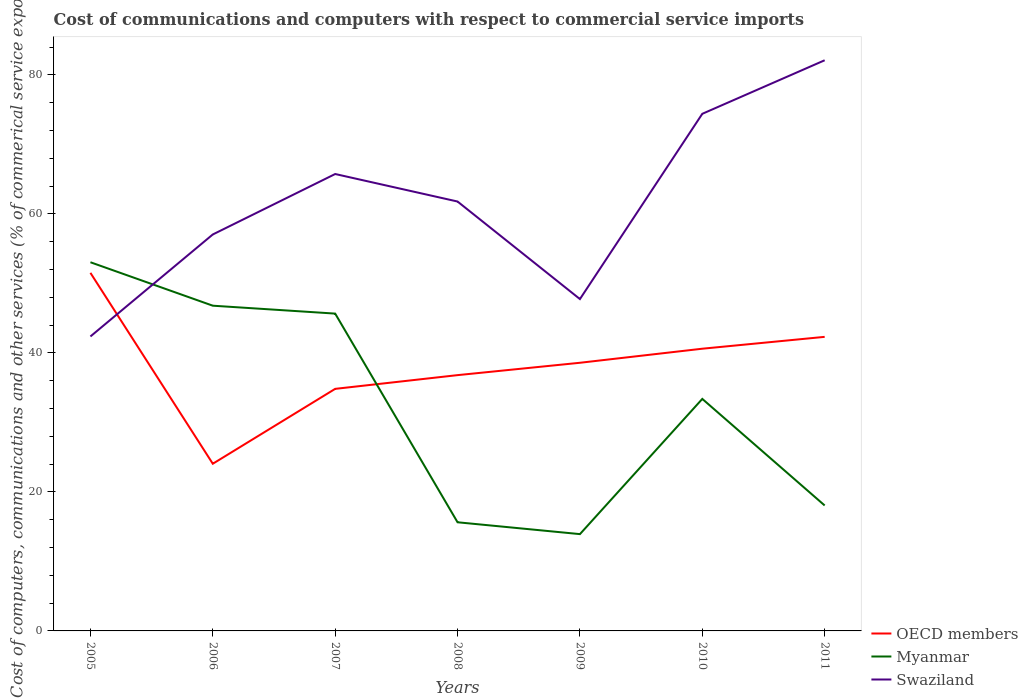How many different coloured lines are there?
Make the answer very short. 3. Across all years, what is the maximum cost of communications and computers in Myanmar?
Your response must be concise. 13.93. What is the total cost of communications and computers in Swaziland in the graph?
Offer a very short reply. -4.74. What is the difference between the highest and the second highest cost of communications and computers in Myanmar?
Ensure brevity in your answer.  39.11. What is the difference between the highest and the lowest cost of communications and computers in Swaziland?
Ensure brevity in your answer.  4. Is the cost of communications and computers in OECD members strictly greater than the cost of communications and computers in Myanmar over the years?
Provide a short and direct response. No. How many legend labels are there?
Ensure brevity in your answer.  3. What is the title of the graph?
Give a very brief answer. Cost of communications and computers with respect to commercial service imports. What is the label or title of the X-axis?
Provide a succinct answer. Years. What is the label or title of the Y-axis?
Provide a short and direct response. Cost of computers, communications and other services (% of commerical service exports). What is the Cost of computers, communications and other services (% of commerical service exports) in OECD members in 2005?
Provide a short and direct response. 51.51. What is the Cost of computers, communications and other services (% of commerical service exports) of Myanmar in 2005?
Your answer should be very brief. 53.04. What is the Cost of computers, communications and other services (% of commerical service exports) of Swaziland in 2005?
Ensure brevity in your answer.  42.36. What is the Cost of computers, communications and other services (% of commerical service exports) in OECD members in 2006?
Keep it short and to the point. 24.05. What is the Cost of computers, communications and other services (% of commerical service exports) of Myanmar in 2006?
Make the answer very short. 46.79. What is the Cost of computers, communications and other services (% of commerical service exports) in Swaziland in 2006?
Your answer should be very brief. 57.03. What is the Cost of computers, communications and other services (% of commerical service exports) of OECD members in 2007?
Your answer should be very brief. 34.82. What is the Cost of computers, communications and other services (% of commerical service exports) in Myanmar in 2007?
Provide a short and direct response. 45.65. What is the Cost of computers, communications and other services (% of commerical service exports) of Swaziland in 2007?
Make the answer very short. 65.73. What is the Cost of computers, communications and other services (% of commerical service exports) of OECD members in 2008?
Keep it short and to the point. 36.8. What is the Cost of computers, communications and other services (% of commerical service exports) of Myanmar in 2008?
Provide a short and direct response. 15.63. What is the Cost of computers, communications and other services (% of commerical service exports) in Swaziland in 2008?
Offer a very short reply. 61.77. What is the Cost of computers, communications and other services (% of commerical service exports) of OECD members in 2009?
Offer a very short reply. 38.57. What is the Cost of computers, communications and other services (% of commerical service exports) in Myanmar in 2009?
Your answer should be very brief. 13.93. What is the Cost of computers, communications and other services (% of commerical service exports) in Swaziland in 2009?
Offer a very short reply. 47.74. What is the Cost of computers, communications and other services (% of commerical service exports) in OECD members in 2010?
Offer a very short reply. 40.6. What is the Cost of computers, communications and other services (% of commerical service exports) in Myanmar in 2010?
Give a very brief answer. 33.38. What is the Cost of computers, communications and other services (% of commerical service exports) of Swaziland in 2010?
Keep it short and to the point. 74.39. What is the Cost of computers, communications and other services (% of commerical service exports) in OECD members in 2011?
Provide a succinct answer. 42.3. What is the Cost of computers, communications and other services (% of commerical service exports) in Myanmar in 2011?
Provide a short and direct response. 18.05. What is the Cost of computers, communications and other services (% of commerical service exports) of Swaziland in 2011?
Provide a succinct answer. 82.09. Across all years, what is the maximum Cost of computers, communications and other services (% of commerical service exports) in OECD members?
Your response must be concise. 51.51. Across all years, what is the maximum Cost of computers, communications and other services (% of commerical service exports) in Myanmar?
Provide a succinct answer. 53.04. Across all years, what is the maximum Cost of computers, communications and other services (% of commerical service exports) of Swaziland?
Give a very brief answer. 82.09. Across all years, what is the minimum Cost of computers, communications and other services (% of commerical service exports) in OECD members?
Provide a succinct answer. 24.05. Across all years, what is the minimum Cost of computers, communications and other services (% of commerical service exports) in Myanmar?
Ensure brevity in your answer.  13.93. Across all years, what is the minimum Cost of computers, communications and other services (% of commerical service exports) of Swaziland?
Give a very brief answer. 42.36. What is the total Cost of computers, communications and other services (% of commerical service exports) in OECD members in the graph?
Keep it short and to the point. 268.66. What is the total Cost of computers, communications and other services (% of commerical service exports) of Myanmar in the graph?
Keep it short and to the point. 226.45. What is the total Cost of computers, communications and other services (% of commerical service exports) of Swaziland in the graph?
Provide a short and direct response. 431.12. What is the difference between the Cost of computers, communications and other services (% of commerical service exports) of OECD members in 2005 and that in 2006?
Keep it short and to the point. 27.46. What is the difference between the Cost of computers, communications and other services (% of commerical service exports) in Myanmar in 2005 and that in 2006?
Keep it short and to the point. 6.25. What is the difference between the Cost of computers, communications and other services (% of commerical service exports) of Swaziland in 2005 and that in 2006?
Your response must be concise. -14.67. What is the difference between the Cost of computers, communications and other services (% of commerical service exports) in OECD members in 2005 and that in 2007?
Your response must be concise. 16.69. What is the difference between the Cost of computers, communications and other services (% of commerical service exports) of Myanmar in 2005 and that in 2007?
Make the answer very short. 7.39. What is the difference between the Cost of computers, communications and other services (% of commerical service exports) of Swaziland in 2005 and that in 2007?
Ensure brevity in your answer.  -23.37. What is the difference between the Cost of computers, communications and other services (% of commerical service exports) of OECD members in 2005 and that in 2008?
Ensure brevity in your answer.  14.71. What is the difference between the Cost of computers, communications and other services (% of commerical service exports) in Myanmar in 2005 and that in 2008?
Provide a succinct answer. 37.41. What is the difference between the Cost of computers, communications and other services (% of commerical service exports) of Swaziland in 2005 and that in 2008?
Keep it short and to the point. -19.41. What is the difference between the Cost of computers, communications and other services (% of commerical service exports) of OECD members in 2005 and that in 2009?
Offer a very short reply. 12.94. What is the difference between the Cost of computers, communications and other services (% of commerical service exports) of Myanmar in 2005 and that in 2009?
Ensure brevity in your answer.  39.11. What is the difference between the Cost of computers, communications and other services (% of commerical service exports) of Swaziland in 2005 and that in 2009?
Ensure brevity in your answer.  -5.38. What is the difference between the Cost of computers, communications and other services (% of commerical service exports) of OECD members in 2005 and that in 2010?
Offer a terse response. 10.91. What is the difference between the Cost of computers, communications and other services (% of commerical service exports) in Myanmar in 2005 and that in 2010?
Your answer should be compact. 19.66. What is the difference between the Cost of computers, communications and other services (% of commerical service exports) of Swaziland in 2005 and that in 2010?
Your response must be concise. -32.03. What is the difference between the Cost of computers, communications and other services (% of commerical service exports) of OECD members in 2005 and that in 2011?
Provide a succinct answer. 9.21. What is the difference between the Cost of computers, communications and other services (% of commerical service exports) of Myanmar in 2005 and that in 2011?
Ensure brevity in your answer.  34.99. What is the difference between the Cost of computers, communications and other services (% of commerical service exports) in Swaziland in 2005 and that in 2011?
Provide a short and direct response. -39.73. What is the difference between the Cost of computers, communications and other services (% of commerical service exports) in OECD members in 2006 and that in 2007?
Offer a terse response. -10.77. What is the difference between the Cost of computers, communications and other services (% of commerical service exports) of Myanmar in 2006 and that in 2007?
Make the answer very short. 1.14. What is the difference between the Cost of computers, communications and other services (% of commerical service exports) in Swaziland in 2006 and that in 2007?
Provide a succinct answer. -8.7. What is the difference between the Cost of computers, communications and other services (% of commerical service exports) in OECD members in 2006 and that in 2008?
Offer a terse response. -12.75. What is the difference between the Cost of computers, communications and other services (% of commerical service exports) in Myanmar in 2006 and that in 2008?
Provide a short and direct response. 31.16. What is the difference between the Cost of computers, communications and other services (% of commerical service exports) in Swaziland in 2006 and that in 2008?
Provide a short and direct response. -4.74. What is the difference between the Cost of computers, communications and other services (% of commerical service exports) of OECD members in 2006 and that in 2009?
Provide a succinct answer. -14.53. What is the difference between the Cost of computers, communications and other services (% of commerical service exports) in Myanmar in 2006 and that in 2009?
Your answer should be compact. 32.86. What is the difference between the Cost of computers, communications and other services (% of commerical service exports) of Swaziland in 2006 and that in 2009?
Offer a very short reply. 9.29. What is the difference between the Cost of computers, communications and other services (% of commerical service exports) of OECD members in 2006 and that in 2010?
Offer a very short reply. -16.55. What is the difference between the Cost of computers, communications and other services (% of commerical service exports) in Myanmar in 2006 and that in 2010?
Provide a succinct answer. 13.41. What is the difference between the Cost of computers, communications and other services (% of commerical service exports) of Swaziland in 2006 and that in 2010?
Provide a short and direct response. -17.36. What is the difference between the Cost of computers, communications and other services (% of commerical service exports) in OECD members in 2006 and that in 2011?
Make the answer very short. -18.26. What is the difference between the Cost of computers, communications and other services (% of commerical service exports) of Myanmar in 2006 and that in 2011?
Your response must be concise. 28.74. What is the difference between the Cost of computers, communications and other services (% of commerical service exports) of Swaziland in 2006 and that in 2011?
Keep it short and to the point. -25.06. What is the difference between the Cost of computers, communications and other services (% of commerical service exports) of OECD members in 2007 and that in 2008?
Your answer should be very brief. -1.97. What is the difference between the Cost of computers, communications and other services (% of commerical service exports) in Myanmar in 2007 and that in 2008?
Offer a terse response. 30.02. What is the difference between the Cost of computers, communications and other services (% of commerical service exports) of Swaziland in 2007 and that in 2008?
Make the answer very short. 3.96. What is the difference between the Cost of computers, communications and other services (% of commerical service exports) of OECD members in 2007 and that in 2009?
Keep it short and to the point. -3.75. What is the difference between the Cost of computers, communications and other services (% of commerical service exports) of Myanmar in 2007 and that in 2009?
Your answer should be compact. 31.72. What is the difference between the Cost of computers, communications and other services (% of commerical service exports) in Swaziland in 2007 and that in 2009?
Your answer should be very brief. 17.99. What is the difference between the Cost of computers, communications and other services (% of commerical service exports) in OECD members in 2007 and that in 2010?
Keep it short and to the point. -5.78. What is the difference between the Cost of computers, communications and other services (% of commerical service exports) of Myanmar in 2007 and that in 2010?
Give a very brief answer. 12.27. What is the difference between the Cost of computers, communications and other services (% of commerical service exports) of Swaziland in 2007 and that in 2010?
Give a very brief answer. -8.66. What is the difference between the Cost of computers, communications and other services (% of commerical service exports) of OECD members in 2007 and that in 2011?
Your answer should be compact. -7.48. What is the difference between the Cost of computers, communications and other services (% of commerical service exports) of Myanmar in 2007 and that in 2011?
Keep it short and to the point. 27.6. What is the difference between the Cost of computers, communications and other services (% of commerical service exports) of Swaziland in 2007 and that in 2011?
Make the answer very short. -16.36. What is the difference between the Cost of computers, communications and other services (% of commerical service exports) of OECD members in 2008 and that in 2009?
Offer a very short reply. -1.78. What is the difference between the Cost of computers, communications and other services (% of commerical service exports) of Myanmar in 2008 and that in 2009?
Your answer should be compact. 1.7. What is the difference between the Cost of computers, communications and other services (% of commerical service exports) of Swaziland in 2008 and that in 2009?
Offer a very short reply. 14.03. What is the difference between the Cost of computers, communications and other services (% of commerical service exports) in OECD members in 2008 and that in 2010?
Your answer should be very brief. -3.8. What is the difference between the Cost of computers, communications and other services (% of commerical service exports) of Myanmar in 2008 and that in 2010?
Offer a very short reply. -17.75. What is the difference between the Cost of computers, communications and other services (% of commerical service exports) in Swaziland in 2008 and that in 2010?
Your response must be concise. -12.62. What is the difference between the Cost of computers, communications and other services (% of commerical service exports) in OECD members in 2008 and that in 2011?
Give a very brief answer. -5.51. What is the difference between the Cost of computers, communications and other services (% of commerical service exports) in Myanmar in 2008 and that in 2011?
Your answer should be very brief. -2.42. What is the difference between the Cost of computers, communications and other services (% of commerical service exports) of Swaziland in 2008 and that in 2011?
Offer a very short reply. -20.32. What is the difference between the Cost of computers, communications and other services (% of commerical service exports) of OECD members in 2009 and that in 2010?
Give a very brief answer. -2.02. What is the difference between the Cost of computers, communications and other services (% of commerical service exports) of Myanmar in 2009 and that in 2010?
Your answer should be compact. -19.45. What is the difference between the Cost of computers, communications and other services (% of commerical service exports) in Swaziland in 2009 and that in 2010?
Offer a terse response. -26.65. What is the difference between the Cost of computers, communications and other services (% of commerical service exports) in OECD members in 2009 and that in 2011?
Provide a succinct answer. -3.73. What is the difference between the Cost of computers, communications and other services (% of commerical service exports) in Myanmar in 2009 and that in 2011?
Provide a short and direct response. -4.12. What is the difference between the Cost of computers, communications and other services (% of commerical service exports) in Swaziland in 2009 and that in 2011?
Provide a short and direct response. -34.35. What is the difference between the Cost of computers, communications and other services (% of commerical service exports) in OECD members in 2010 and that in 2011?
Make the answer very short. -1.71. What is the difference between the Cost of computers, communications and other services (% of commerical service exports) of Myanmar in 2010 and that in 2011?
Provide a succinct answer. 15.33. What is the difference between the Cost of computers, communications and other services (% of commerical service exports) in Swaziland in 2010 and that in 2011?
Provide a succinct answer. -7.7. What is the difference between the Cost of computers, communications and other services (% of commerical service exports) in OECD members in 2005 and the Cost of computers, communications and other services (% of commerical service exports) in Myanmar in 2006?
Provide a short and direct response. 4.73. What is the difference between the Cost of computers, communications and other services (% of commerical service exports) in OECD members in 2005 and the Cost of computers, communications and other services (% of commerical service exports) in Swaziland in 2006?
Offer a terse response. -5.52. What is the difference between the Cost of computers, communications and other services (% of commerical service exports) of Myanmar in 2005 and the Cost of computers, communications and other services (% of commerical service exports) of Swaziland in 2006?
Your response must be concise. -4. What is the difference between the Cost of computers, communications and other services (% of commerical service exports) in OECD members in 2005 and the Cost of computers, communications and other services (% of commerical service exports) in Myanmar in 2007?
Your answer should be compact. 5.86. What is the difference between the Cost of computers, communications and other services (% of commerical service exports) of OECD members in 2005 and the Cost of computers, communications and other services (% of commerical service exports) of Swaziland in 2007?
Your answer should be very brief. -14.22. What is the difference between the Cost of computers, communications and other services (% of commerical service exports) in Myanmar in 2005 and the Cost of computers, communications and other services (% of commerical service exports) in Swaziland in 2007?
Offer a terse response. -12.69. What is the difference between the Cost of computers, communications and other services (% of commerical service exports) in OECD members in 2005 and the Cost of computers, communications and other services (% of commerical service exports) in Myanmar in 2008?
Give a very brief answer. 35.88. What is the difference between the Cost of computers, communications and other services (% of commerical service exports) of OECD members in 2005 and the Cost of computers, communications and other services (% of commerical service exports) of Swaziland in 2008?
Keep it short and to the point. -10.26. What is the difference between the Cost of computers, communications and other services (% of commerical service exports) in Myanmar in 2005 and the Cost of computers, communications and other services (% of commerical service exports) in Swaziland in 2008?
Keep it short and to the point. -8.74. What is the difference between the Cost of computers, communications and other services (% of commerical service exports) of OECD members in 2005 and the Cost of computers, communications and other services (% of commerical service exports) of Myanmar in 2009?
Your answer should be very brief. 37.59. What is the difference between the Cost of computers, communications and other services (% of commerical service exports) of OECD members in 2005 and the Cost of computers, communications and other services (% of commerical service exports) of Swaziland in 2009?
Keep it short and to the point. 3.77. What is the difference between the Cost of computers, communications and other services (% of commerical service exports) of Myanmar in 2005 and the Cost of computers, communications and other services (% of commerical service exports) of Swaziland in 2009?
Offer a terse response. 5.3. What is the difference between the Cost of computers, communications and other services (% of commerical service exports) of OECD members in 2005 and the Cost of computers, communications and other services (% of commerical service exports) of Myanmar in 2010?
Give a very brief answer. 18.13. What is the difference between the Cost of computers, communications and other services (% of commerical service exports) of OECD members in 2005 and the Cost of computers, communications and other services (% of commerical service exports) of Swaziland in 2010?
Give a very brief answer. -22.88. What is the difference between the Cost of computers, communications and other services (% of commerical service exports) of Myanmar in 2005 and the Cost of computers, communications and other services (% of commerical service exports) of Swaziland in 2010?
Keep it short and to the point. -21.36. What is the difference between the Cost of computers, communications and other services (% of commerical service exports) in OECD members in 2005 and the Cost of computers, communications and other services (% of commerical service exports) in Myanmar in 2011?
Make the answer very short. 33.46. What is the difference between the Cost of computers, communications and other services (% of commerical service exports) of OECD members in 2005 and the Cost of computers, communications and other services (% of commerical service exports) of Swaziland in 2011?
Ensure brevity in your answer.  -30.58. What is the difference between the Cost of computers, communications and other services (% of commerical service exports) of Myanmar in 2005 and the Cost of computers, communications and other services (% of commerical service exports) of Swaziland in 2011?
Give a very brief answer. -29.06. What is the difference between the Cost of computers, communications and other services (% of commerical service exports) of OECD members in 2006 and the Cost of computers, communications and other services (% of commerical service exports) of Myanmar in 2007?
Keep it short and to the point. -21.6. What is the difference between the Cost of computers, communications and other services (% of commerical service exports) in OECD members in 2006 and the Cost of computers, communications and other services (% of commerical service exports) in Swaziland in 2007?
Offer a terse response. -41.68. What is the difference between the Cost of computers, communications and other services (% of commerical service exports) of Myanmar in 2006 and the Cost of computers, communications and other services (% of commerical service exports) of Swaziland in 2007?
Provide a short and direct response. -18.94. What is the difference between the Cost of computers, communications and other services (% of commerical service exports) of OECD members in 2006 and the Cost of computers, communications and other services (% of commerical service exports) of Myanmar in 2008?
Give a very brief answer. 8.42. What is the difference between the Cost of computers, communications and other services (% of commerical service exports) in OECD members in 2006 and the Cost of computers, communications and other services (% of commerical service exports) in Swaziland in 2008?
Your answer should be very brief. -37.72. What is the difference between the Cost of computers, communications and other services (% of commerical service exports) in Myanmar in 2006 and the Cost of computers, communications and other services (% of commerical service exports) in Swaziland in 2008?
Your answer should be compact. -14.99. What is the difference between the Cost of computers, communications and other services (% of commerical service exports) in OECD members in 2006 and the Cost of computers, communications and other services (% of commerical service exports) in Myanmar in 2009?
Keep it short and to the point. 10.12. What is the difference between the Cost of computers, communications and other services (% of commerical service exports) in OECD members in 2006 and the Cost of computers, communications and other services (% of commerical service exports) in Swaziland in 2009?
Make the answer very short. -23.69. What is the difference between the Cost of computers, communications and other services (% of commerical service exports) of Myanmar in 2006 and the Cost of computers, communications and other services (% of commerical service exports) of Swaziland in 2009?
Give a very brief answer. -0.95. What is the difference between the Cost of computers, communications and other services (% of commerical service exports) of OECD members in 2006 and the Cost of computers, communications and other services (% of commerical service exports) of Myanmar in 2010?
Give a very brief answer. -9.33. What is the difference between the Cost of computers, communications and other services (% of commerical service exports) of OECD members in 2006 and the Cost of computers, communications and other services (% of commerical service exports) of Swaziland in 2010?
Make the answer very short. -50.34. What is the difference between the Cost of computers, communications and other services (% of commerical service exports) of Myanmar in 2006 and the Cost of computers, communications and other services (% of commerical service exports) of Swaziland in 2010?
Provide a succinct answer. -27.61. What is the difference between the Cost of computers, communications and other services (% of commerical service exports) in OECD members in 2006 and the Cost of computers, communications and other services (% of commerical service exports) in Myanmar in 2011?
Ensure brevity in your answer.  6. What is the difference between the Cost of computers, communications and other services (% of commerical service exports) of OECD members in 2006 and the Cost of computers, communications and other services (% of commerical service exports) of Swaziland in 2011?
Your response must be concise. -58.04. What is the difference between the Cost of computers, communications and other services (% of commerical service exports) of Myanmar in 2006 and the Cost of computers, communications and other services (% of commerical service exports) of Swaziland in 2011?
Provide a short and direct response. -35.31. What is the difference between the Cost of computers, communications and other services (% of commerical service exports) in OECD members in 2007 and the Cost of computers, communications and other services (% of commerical service exports) in Myanmar in 2008?
Make the answer very short. 19.19. What is the difference between the Cost of computers, communications and other services (% of commerical service exports) of OECD members in 2007 and the Cost of computers, communications and other services (% of commerical service exports) of Swaziland in 2008?
Ensure brevity in your answer.  -26.95. What is the difference between the Cost of computers, communications and other services (% of commerical service exports) in Myanmar in 2007 and the Cost of computers, communications and other services (% of commerical service exports) in Swaziland in 2008?
Make the answer very short. -16.12. What is the difference between the Cost of computers, communications and other services (% of commerical service exports) of OECD members in 2007 and the Cost of computers, communications and other services (% of commerical service exports) of Myanmar in 2009?
Your response must be concise. 20.9. What is the difference between the Cost of computers, communications and other services (% of commerical service exports) of OECD members in 2007 and the Cost of computers, communications and other services (% of commerical service exports) of Swaziland in 2009?
Keep it short and to the point. -12.92. What is the difference between the Cost of computers, communications and other services (% of commerical service exports) of Myanmar in 2007 and the Cost of computers, communications and other services (% of commerical service exports) of Swaziland in 2009?
Keep it short and to the point. -2.09. What is the difference between the Cost of computers, communications and other services (% of commerical service exports) of OECD members in 2007 and the Cost of computers, communications and other services (% of commerical service exports) of Myanmar in 2010?
Offer a very short reply. 1.44. What is the difference between the Cost of computers, communications and other services (% of commerical service exports) in OECD members in 2007 and the Cost of computers, communications and other services (% of commerical service exports) in Swaziland in 2010?
Offer a terse response. -39.57. What is the difference between the Cost of computers, communications and other services (% of commerical service exports) of Myanmar in 2007 and the Cost of computers, communications and other services (% of commerical service exports) of Swaziland in 2010?
Your response must be concise. -28.74. What is the difference between the Cost of computers, communications and other services (% of commerical service exports) in OECD members in 2007 and the Cost of computers, communications and other services (% of commerical service exports) in Myanmar in 2011?
Make the answer very short. 16.77. What is the difference between the Cost of computers, communications and other services (% of commerical service exports) in OECD members in 2007 and the Cost of computers, communications and other services (% of commerical service exports) in Swaziland in 2011?
Provide a succinct answer. -47.27. What is the difference between the Cost of computers, communications and other services (% of commerical service exports) in Myanmar in 2007 and the Cost of computers, communications and other services (% of commerical service exports) in Swaziland in 2011?
Provide a short and direct response. -36.44. What is the difference between the Cost of computers, communications and other services (% of commerical service exports) in OECD members in 2008 and the Cost of computers, communications and other services (% of commerical service exports) in Myanmar in 2009?
Your answer should be very brief. 22.87. What is the difference between the Cost of computers, communications and other services (% of commerical service exports) in OECD members in 2008 and the Cost of computers, communications and other services (% of commerical service exports) in Swaziland in 2009?
Your response must be concise. -10.94. What is the difference between the Cost of computers, communications and other services (% of commerical service exports) in Myanmar in 2008 and the Cost of computers, communications and other services (% of commerical service exports) in Swaziland in 2009?
Provide a short and direct response. -32.11. What is the difference between the Cost of computers, communications and other services (% of commerical service exports) in OECD members in 2008 and the Cost of computers, communications and other services (% of commerical service exports) in Myanmar in 2010?
Your response must be concise. 3.42. What is the difference between the Cost of computers, communications and other services (% of commerical service exports) in OECD members in 2008 and the Cost of computers, communications and other services (% of commerical service exports) in Swaziland in 2010?
Offer a terse response. -37.59. What is the difference between the Cost of computers, communications and other services (% of commerical service exports) of Myanmar in 2008 and the Cost of computers, communications and other services (% of commerical service exports) of Swaziland in 2010?
Give a very brief answer. -58.76. What is the difference between the Cost of computers, communications and other services (% of commerical service exports) in OECD members in 2008 and the Cost of computers, communications and other services (% of commerical service exports) in Myanmar in 2011?
Keep it short and to the point. 18.75. What is the difference between the Cost of computers, communications and other services (% of commerical service exports) in OECD members in 2008 and the Cost of computers, communications and other services (% of commerical service exports) in Swaziland in 2011?
Your answer should be compact. -45.3. What is the difference between the Cost of computers, communications and other services (% of commerical service exports) in Myanmar in 2008 and the Cost of computers, communications and other services (% of commerical service exports) in Swaziland in 2011?
Provide a succinct answer. -66.46. What is the difference between the Cost of computers, communications and other services (% of commerical service exports) in OECD members in 2009 and the Cost of computers, communications and other services (% of commerical service exports) in Myanmar in 2010?
Provide a succinct answer. 5.2. What is the difference between the Cost of computers, communications and other services (% of commerical service exports) in OECD members in 2009 and the Cost of computers, communications and other services (% of commerical service exports) in Swaziland in 2010?
Ensure brevity in your answer.  -35.82. What is the difference between the Cost of computers, communications and other services (% of commerical service exports) in Myanmar in 2009 and the Cost of computers, communications and other services (% of commerical service exports) in Swaziland in 2010?
Keep it short and to the point. -60.47. What is the difference between the Cost of computers, communications and other services (% of commerical service exports) of OECD members in 2009 and the Cost of computers, communications and other services (% of commerical service exports) of Myanmar in 2011?
Your response must be concise. 20.53. What is the difference between the Cost of computers, communications and other services (% of commerical service exports) in OECD members in 2009 and the Cost of computers, communications and other services (% of commerical service exports) in Swaziland in 2011?
Your answer should be very brief. -43.52. What is the difference between the Cost of computers, communications and other services (% of commerical service exports) in Myanmar in 2009 and the Cost of computers, communications and other services (% of commerical service exports) in Swaziland in 2011?
Your answer should be compact. -68.17. What is the difference between the Cost of computers, communications and other services (% of commerical service exports) of OECD members in 2010 and the Cost of computers, communications and other services (% of commerical service exports) of Myanmar in 2011?
Provide a short and direct response. 22.55. What is the difference between the Cost of computers, communications and other services (% of commerical service exports) of OECD members in 2010 and the Cost of computers, communications and other services (% of commerical service exports) of Swaziland in 2011?
Keep it short and to the point. -41.5. What is the difference between the Cost of computers, communications and other services (% of commerical service exports) in Myanmar in 2010 and the Cost of computers, communications and other services (% of commerical service exports) in Swaziland in 2011?
Provide a short and direct response. -48.72. What is the average Cost of computers, communications and other services (% of commerical service exports) of OECD members per year?
Offer a terse response. 38.38. What is the average Cost of computers, communications and other services (% of commerical service exports) in Myanmar per year?
Your response must be concise. 32.35. What is the average Cost of computers, communications and other services (% of commerical service exports) in Swaziland per year?
Your response must be concise. 61.59. In the year 2005, what is the difference between the Cost of computers, communications and other services (% of commerical service exports) in OECD members and Cost of computers, communications and other services (% of commerical service exports) in Myanmar?
Make the answer very short. -1.52. In the year 2005, what is the difference between the Cost of computers, communications and other services (% of commerical service exports) of OECD members and Cost of computers, communications and other services (% of commerical service exports) of Swaziland?
Offer a terse response. 9.15. In the year 2005, what is the difference between the Cost of computers, communications and other services (% of commerical service exports) of Myanmar and Cost of computers, communications and other services (% of commerical service exports) of Swaziland?
Your answer should be compact. 10.68. In the year 2006, what is the difference between the Cost of computers, communications and other services (% of commerical service exports) in OECD members and Cost of computers, communications and other services (% of commerical service exports) in Myanmar?
Keep it short and to the point. -22.74. In the year 2006, what is the difference between the Cost of computers, communications and other services (% of commerical service exports) in OECD members and Cost of computers, communications and other services (% of commerical service exports) in Swaziland?
Provide a short and direct response. -32.99. In the year 2006, what is the difference between the Cost of computers, communications and other services (% of commerical service exports) of Myanmar and Cost of computers, communications and other services (% of commerical service exports) of Swaziland?
Ensure brevity in your answer.  -10.25. In the year 2007, what is the difference between the Cost of computers, communications and other services (% of commerical service exports) of OECD members and Cost of computers, communications and other services (% of commerical service exports) of Myanmar?
Your response must be concise. -10.83. In the year 2007, what is the difference between the Cost of computers, communications and other services (% of commerical service exports) in OECD members and Cost of computers, communications and other services (% of commerical service exports) in Swaziland?
Offer a very short reply. -30.91. In the year 2007, what is the difference between the Cost of computers, communications and other services (% of commerical service exports) of Myanmar and Cost of computers, communications and other services (% of commerical service exports) of Swaziland?
Give a very brief answer. -20.08. In the year 2008, what is the difference between the Cost of computers, communications and other services (% of commerical service exports) in OECD members and Cost of computers, communications and other services (% of commerical service exports) in Myanmar?
Keep it short and to the point. 21.17. In the year 2008, what is the difference between the Cost of computers, communications and other services (% of commerical service exports) in OECD members and Cost of computers, communications and other services (% of commerical service exports) in Swaziland?
Provide a succinct answer. -24.98. In the year 2008, what is the difference between the Cost of computers, communications and other services (% of commerical service exports) of Myanmar and Cost of computers, communications and other services (% of commerical service exports) of Swaziland?
Make the answer very short. -46.14. In the year 2009, what is the difference between the Cost of computers, communications and other services (% of commerical service exports) of OECD members and Cost of computers, communications and other services (% of commerical service exports) of Myanmar?
Make the answer very short. 24.65. In the year 2009, what is the difference between the Cost of computers, communications and other services (% of commerical service exports) of OECD members and Cost of computers, communications and other services (% of commerical service exports) of Swaziland?
Keep it short and to the point. -9.17. In the year 2009, what is the difference between the Cost of computers, communications and other services (% of commerical service exports) in Myanmar and Cost of computers, communications and other services (% of commerical service exports) in Swaziland?
Offer a very short reply. -33.82. In the year 2010, what is the difference between the Cost of computers, communications and other services (% of commerical service exports) in OECD members and Cost of computers, communications and other services (% of commerical service exports) in Myanmar?
Provide a short and direct response. 7.22. In the year 2010, what is the difference between the Cost of computers, communications and other services (% of commerical service exports) in OECD members and Cost of computers, communications and other services (% of commerical service exports) in Swaziland?
Provide a succinct answer. -33.79. In the year 2010, what is the difference between the Cost of computers, communications and other services (% of commerical service exports) in Myanmar and Cost of computers, communications and other services (% of commerical service exports) in Swaziland?
Provide a succinct answer. -41.01. In the year 2011, what is the difference between the Cost of computers, communications and other services (% of commerical service exports) of OECD members and Cost of computers, communications and other services (% of commerical service exports) of Myanmar?
Ensure brevity in your answer.  24.26. In the year 2011, what is the difference between the Cost of computers, communications and other services (% of commerical service exports) in OECD members and Cost of computers, communications and other services (% of commerical service exports) in Swaziland?
Your answer should be very brief. -39.79. In the year 2011, what is the difference between the Cost of computers, communications and other services (% of commerical service exports) in Myanmar and Cost of computers, communications and other services (% of commerical service exports) in Swaziland?
Your response must be concise. -64.05. What is the ratio of the Cost of computers, communications and other services (% of commerical service exports) in OECD members in 2005 to that in 2006?
Make the answer very short. 2.14. What is the ratio of the Cost of computers, communications and other services (% of commerical service exports) of Myanmar in 2005 to that in 2006?
Your answer should be very brief. 1.13. What is the ratio of the Cost of computers, communications and other services (% of commerical service exports) of Swaziland in 2005 to that in 2006?
Offer a very short reply. 0.74. What is the ratio of the Cost of computers, communications and other services (% of commerical service exports) in OECD members in 2005 to that in 2007?
Provide a short and direct response. 1.48. What is the ratio of the Cost of computers, communications and other services (% of commerical service exports) in Myanmar in 2005 to that in 2007?
Offer a terse response. 1.16. What is the ratio of the Cost of computers, communications and other services (% of commerical service exports) of Swaziland in 2005 to that in 2007?
Your answer should be very brief. 0.64. What is the ratio of the Cost of computers, communications and other services (% of commerical service exports) in OECD members in 2005 to that in 2008?
Make the answer very short. 1.4. What is the ratio of the Cost of computers, communications and other services (% of commerical service exports) in Myanmar in 2005 to that in 2008?
Provide a short and direct response. 3.39. What is the ratio of the Cost of computers, communications and other services (% of commerical service exports) in Swaziland in 2005 to that in 2008?
Your answer should be compact. 0.69. What is the ratio of the Cost of computers, communications and other services (% of commerical service exports) of OECD members in 2005 to that in 2009?
Offer a terse response. 1.34. What is the ratio of the Cost of computers, communications and other services (% of commerical service exports) in Myanmar in 2005 to that in 2009?
Your answer should be compact. 3.81. What is the ratio of the Cost of computers, communications and other services (% of commerical service exports) of Swaziland in 2005 to that in 2009?
Provide a short and direct response. 0.89. What is the ratio of the Cost of computers, communications and other services (% of commerical service exports) of OECD members in 2005 to that in 2010?
Offer a very short reply. 1.27. What is the ratio of the Cost of computers, communications and other services (% of commerical service exports) of Myanmar in 2005 to that in 2010?
Offer a terse response. 1.59. What is the ratio of the Cost of computers, communications and other services (% of commerical service exports) of Swaziland in 2005 to that in 2010?
Provide a succinct answer. 0.57. What is the ratio of the Cost of computers, communications and other services (% of commerical service exports) of OECD members in 2005 to that in 2011?
Make the answer very short. 1.22. What is the ratio of the Cost of computers, communications and other services (% of commerical service exports) in Myanmar in 2005 to that in 2011?
Provide a succinct answer. 2.94. What is the ratio of the Cost of computers, communications and other services (% of commerical service exports) of Swaziland in 2005 to that in 2011?
Your answer should be very brief. 0.52. What is the ratio of the Cost of computers, communications and other services (% of commerical service exports) in OECD members in 2006 to that in 2007?
Ensure brevity in your answer.  0.69. What is the ratio of the Cost of computers, communications and other services (% of commerical service exports) in Myanmar in 2006 to that in 2007?
Make the answer very short. 1.02. What is the ratio of the Cost of computers, communications and other services (% of commerical service exports) in Swaziland in 2006 to that in 2007?
Offer a terse response. 0.87. What is the ratio of the Cost of computers, communications and other services (% of commerical service exports) in OECD members in 2006 to that in 2008?
Offer a terse response. 0.65. What is the ratio of the Cost of computers, communications and other services (% of commerical service exports) of Myanmar in 2006 to that in 2008?
Provide a short and direct response. 2.99. What is the ratio of the Cost of computers, communications and other services (% of commerical service exports) in Swaziland in 2006 to that in 2008?
Your answer should be compact. 0.92. What is the ratio of the Cost of computers, communications and other services (% of commerical service exports) of OECD members in 2006 to that in 2009?
Provide a succinct answer. 0.62. What is the ratio of the Cost of computers, communications and other services (% of commerical service exports) in Myanmar in 2006 to that in 2009?
Ensure brevity in your answer.  3.36. What is the ratio of the Cost of computers, communications and other services (% of commerical service exports) in Swaziland in 2006 to that in 2009?
Ensure brevity in your answer.  1.19. What is the ratio of the Cost of computers, communications and other services (% of commerical service exports) in OECD members in 2006 to that in 2010?
Make the answer very short. 0.59. What is the ratio of the Cost of computers, communications and other services (% of commerical service exports) of Myanmar in 2006 to that in 2010?
Your response must be concise. 1.4. What is the ratio of the Cost of computers, communications and other services (% of commerical service exports) of Swaziland in 2006 to that in 2010?
Ensure brevity in your answer.  0.77. What is the ratio of the Cost of computers, communications and other services (% of commerical service exports) in OECD members in 2006 to that in 2011?
Provide a succinct answer. 0.57. What is the ratio of the Cost of computers, communications and other services (% of commerical service exports) of Myanmar in 2006 to that in 2011?
Make the answer very short. 2.59. What is the ratio of the Cost of computers, communications and other services (% of commerical service exports) of Swaziland in 2006 to that in 2011?
Provide a short and direct response. 0.69. What is the ratio of the Cost of computers, communications and other services (% of commerical service exports) of OECD members in 2007 to that in 2008?
Ensure brevity in your answer.  0.95. What is the ratio of the Cost of computers, communications and other services (% of commerical service exports) of Myanmar in 2007 to that in 2008?
Ensure brevity in your answer.  2.92. What is the ratio of the Cost of computers, communications and other services (% of commerical service exports) of Swaziland in 2007 to that in 2008?
Give a very brief answer. 1.06. What is the ratio of the Cost of computers, communications and other services (% of commerical service exports) of OECD members in 2007 to that in 2009?
Your answer should be compact. 0.9. What is the ratio of the Cost of computers, communications and other services (% of commerical service exports) of Myanmar in 2007 to that in 2009?
Provide a succinct answer. 3.28. What is the ratio of the Cost of computers, communications and other services (% of commerical service exports) in Swaziland in 2007 to that in 2009?
Give a very brief answer. 1.38. What is the ratio of the Cost of computers, communications and other services (% of commerical service exports) in OECD members in 2007 to that in 2010?
Your answer should be very brief. 0.86. What is the ratio of the Cost of computers, communications and other services (% of commerical service exports) in Myanmar in 2007 to that in 2010?
Your answer should be compact. 1.37. What is the ratio of the Cost of computers, communications and other services (% of commerical service exports) of Swaziland in 2007 to that in 2010?
Keep it short and to the point. 0.88. What is the ratio of the Cost of computers, communications and other services (% of commerical service exports) of OECD members in 2007 to that in 2011?
Offer a very short reply. 0.82. What is the ratio of the Cost of computers, communications and other services (% of commerical service exports) of Myanmar in 2007 to that in 2011?
Offer a terse response. 2.53. What is the ratio of the Cost of computers, communications and other services (% of commerical service exports) of Swaziland in 2007 to that in 2011?
Provide a short and direct response. 0.8. What is the ratio of the Cost of computers, communications and other services (% of commerical service exports) in OECD members in 2008 to that in 2009?
Keep it short and to the point. 0.95. What is the ratio of the Cost of computers, communications and other services (% of commerical service exports) in Myanmar in 2008 to that in 2009?
Provide a succinct answer. 1.12. What is the ratio of the Cost of computers, communications and other services (% of commerical service exports) of Swaziland in 2008 to that in 2009?
Offer a terse response. 1.29. What is the ratio of the Cost of computers, communications and other services (% of commerical service exports) in OECD members in 2008 to that in 2010?
Provide a short and direct response. 0.91. What is the ratio of the Cost of computers, communications and other services (% of commerical service exports) of Myanmar in 2008 to that in 2010?
Offer a very short reply. 0.47. What is the ratio of the Cost of computers, communications and other services (% of commerical service exports) of Swaziland in 2008 to that in 2010?
Ensure brevity in your answer.  0.83. What is the ratio of the Cost of computers, communications and other services (% of commerical service exports) of OECD members in 2008 to that in 2011?
Your answer should be very brief. 0.87. What is the ratio of the Cost of computers, communications and other services (% of commerical service exports) in Myanmar in 2008 to that in 2011?
Your answer should be very brief. 0.87. What is the ratio of the Cost of computers, communications and other services (% of commerical service exports) in Swaziland in 2008 to that in 2011?
Make the answer very short. 0.75. What is the ratio of the Cost of computers, communications and other services (% of commerical service exports) in OECD members in 2009 to that in 2010?
Make the answer very short. 0.95. What is the ratio of the Cost of computers, communications and other services (% of commerical service exports) of Myanmar in 2009 to that in 2010?
Your answer should be compact. 0.42. What is the ratio of the Cost of computers, communications and other services (% of commerical service exports) in Swaziland in 2009 to that in 2010?
Give a very brief answer. 0.64. What is the ratio of the Cost of computers, communications and other services (% of commerical service exports) of OECD members in 2009 to that in 2011?
Keep it short and to the point. 0.91. What is the ratio of the Cost of computers, communications and other services (% of commerical service exports) in Myanmar in 2009 to that in 2011?
Offer a terse response. 0.77. What is the ratio of the Cost of computers, communications and other services (% of commerical service exports) of Swaziland in 2009 to that in 2011?
Ensure brevity in your answer.  0.58. What is the ratio of the Cost of computers, communications and other services (% of commerical service exports) in OECD members in 2010 to that in 2011?
Your response must be concise. 0.96. What is the ratio of the Cost of computers, communications and other services (% of commerical service exports) of Myanmar in 2010 to that in 2011?
Provide a short and direct response. 1.85. What is the ratio of the Cost of computers, communications and other services (% of commerical service exports) of Swaziland in 2010 to that in 2011?
Your answer should be very brief. 0.91. What is the difference between the highest and the second highest Cost of computers, communications and other services (% of commerical service exports) of OECD members?
Your answer should be compact. 9.21. What is the difference between the highest and the second highest Cost of computers, communications and other services (% of commerical service exports) in Myanmar?
Keep it short and to the point. 6.25. What is the difference between the highest and the second highest Cost of computers, communications and other services (% of commerical service exports) in Swaziland?
Keep it short and to the point. 7.7. What is the difference between the highest and the lowest Cost of computers, communications and other services (% of commerical service exports) in OECD members?
Offer a very short reply. 27.46. What is the difference between the highest and the lowest Cost of computers, communications and other services (% of commerical service exports) in Myanmar?
Ensure brevity in your answer.  39.11. What is the difference between the highest and the lowest Cost of computers, communications and other services (% of commerical service exports) in Swaziland?
Provide a short and direct response. 39.73. 